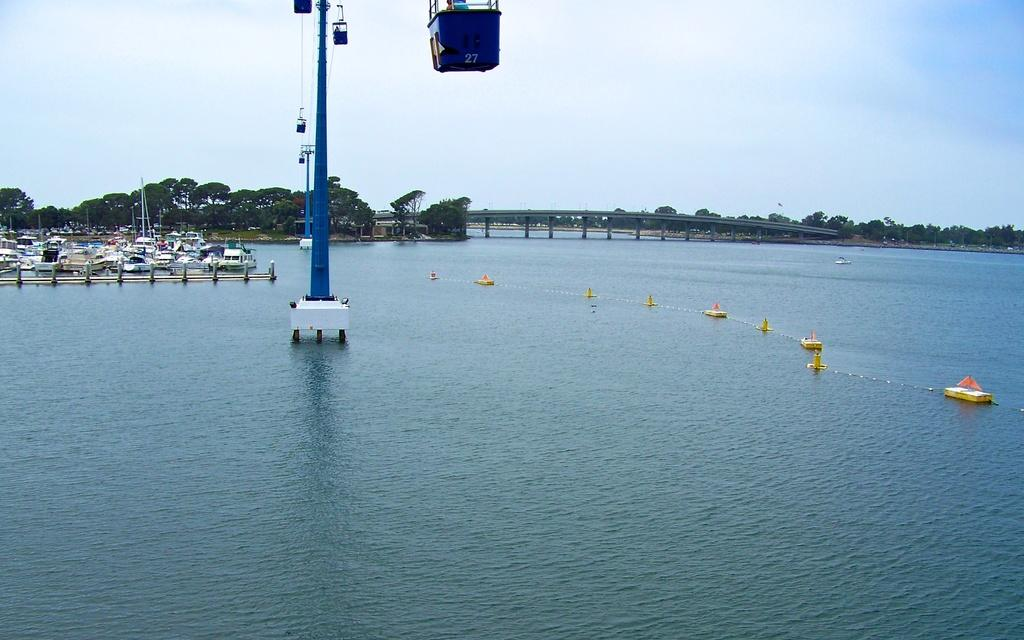What type of transportation system is depicted in the image? There is a ropeway in the image. What can be seen floating on the water in the image? There are objects and boats floating on the water in the image. What structure is present for crossing the water? There is a bridge in the image. What type of natural environment is visible in the background of the image? Trees and the sky are visible in the background of the image. What type of brush is being used to paint the boats in the image? There is no brush or painting activity depicted in the image; it shows a ropeway, floating objects, boats, a bridge, trees, and the sky. 